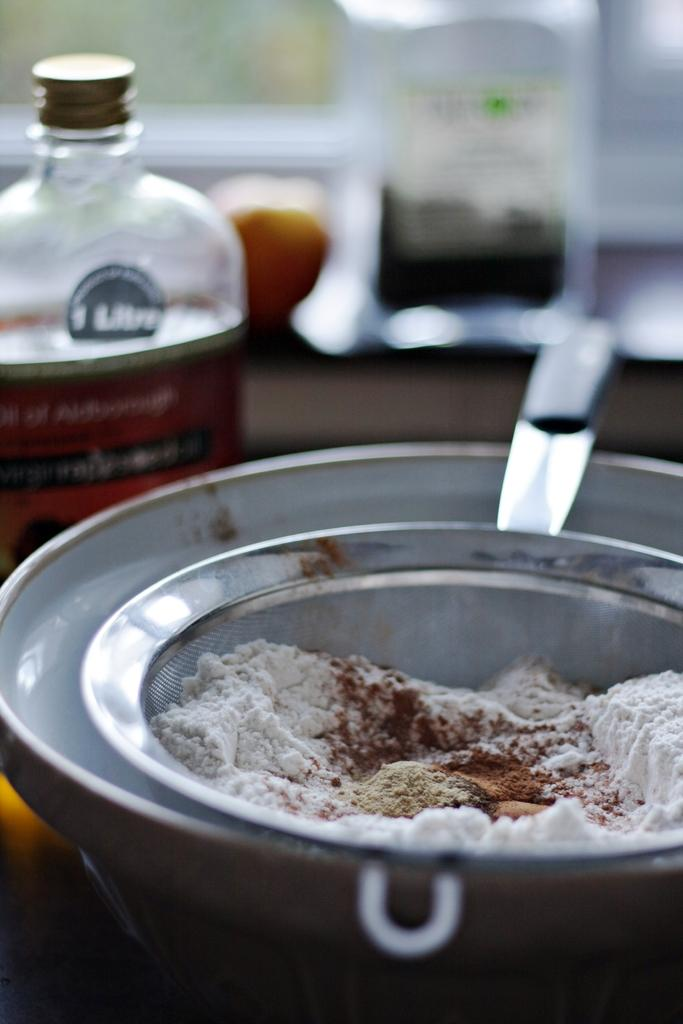What material is the bowl in the image made of? The bowl in the image is made of metal. What is on top of the metal bowl? There is a metal filter on the bowl. What substance is contained within the filter? The filter contains flour. What else can be seen in the image besides the bowl and filter? There is a bottle with a liquid in the image. What type of vein is visible in the image? There are no veins visible in the image; it features a metal bowl, filter, flour, and a bottle with a liquid. 